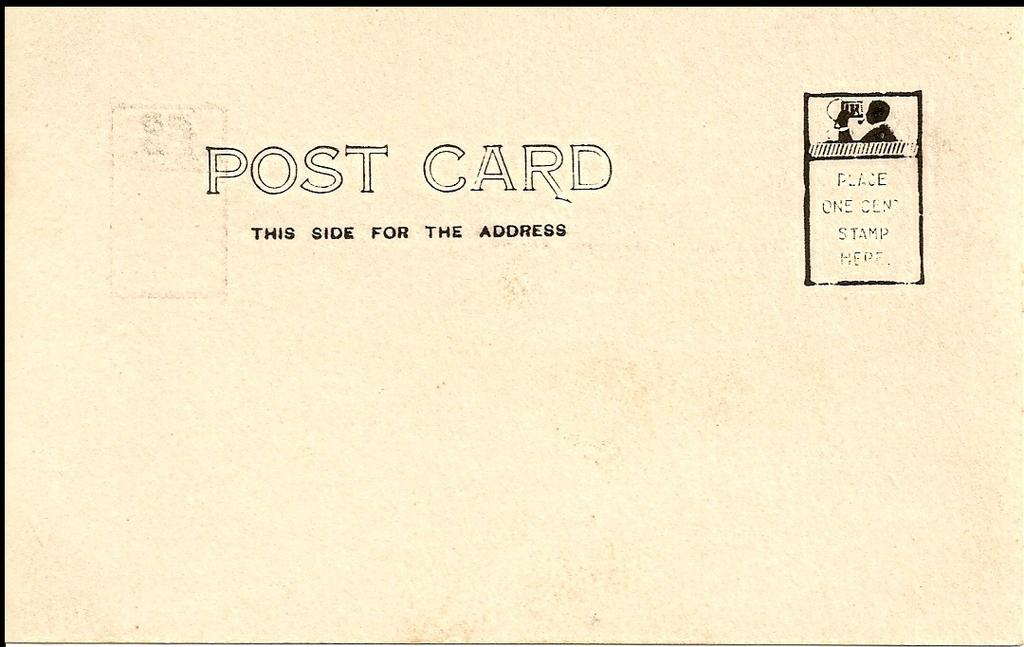What is the main object in the image? There is a postcard in the image. What can be found on the postcard? The postcard has text on it. Reasoning: Let's think step by identifying the main subject in the image, which is the postcard. Then, we expand the conversation to include other details about the postcard, such as the presence of text. Each question is designed to elicit a specific detail about the image that is known from the provided facts. Absurd Question/Answer: What type of furniture is depicted on the postcard? There is no furniture depicted on the postcard, as the facts only mention the presence of text on the postcard. What type of tin can be seen on the postcard? There is no tin present on the postcard, as the facts only mention the presence of text on the postcard. What does the mother on the postcard say? There is no mention of a mother or any dialogue on the postcard, as the facts only mention the presence of text on the postcard. 